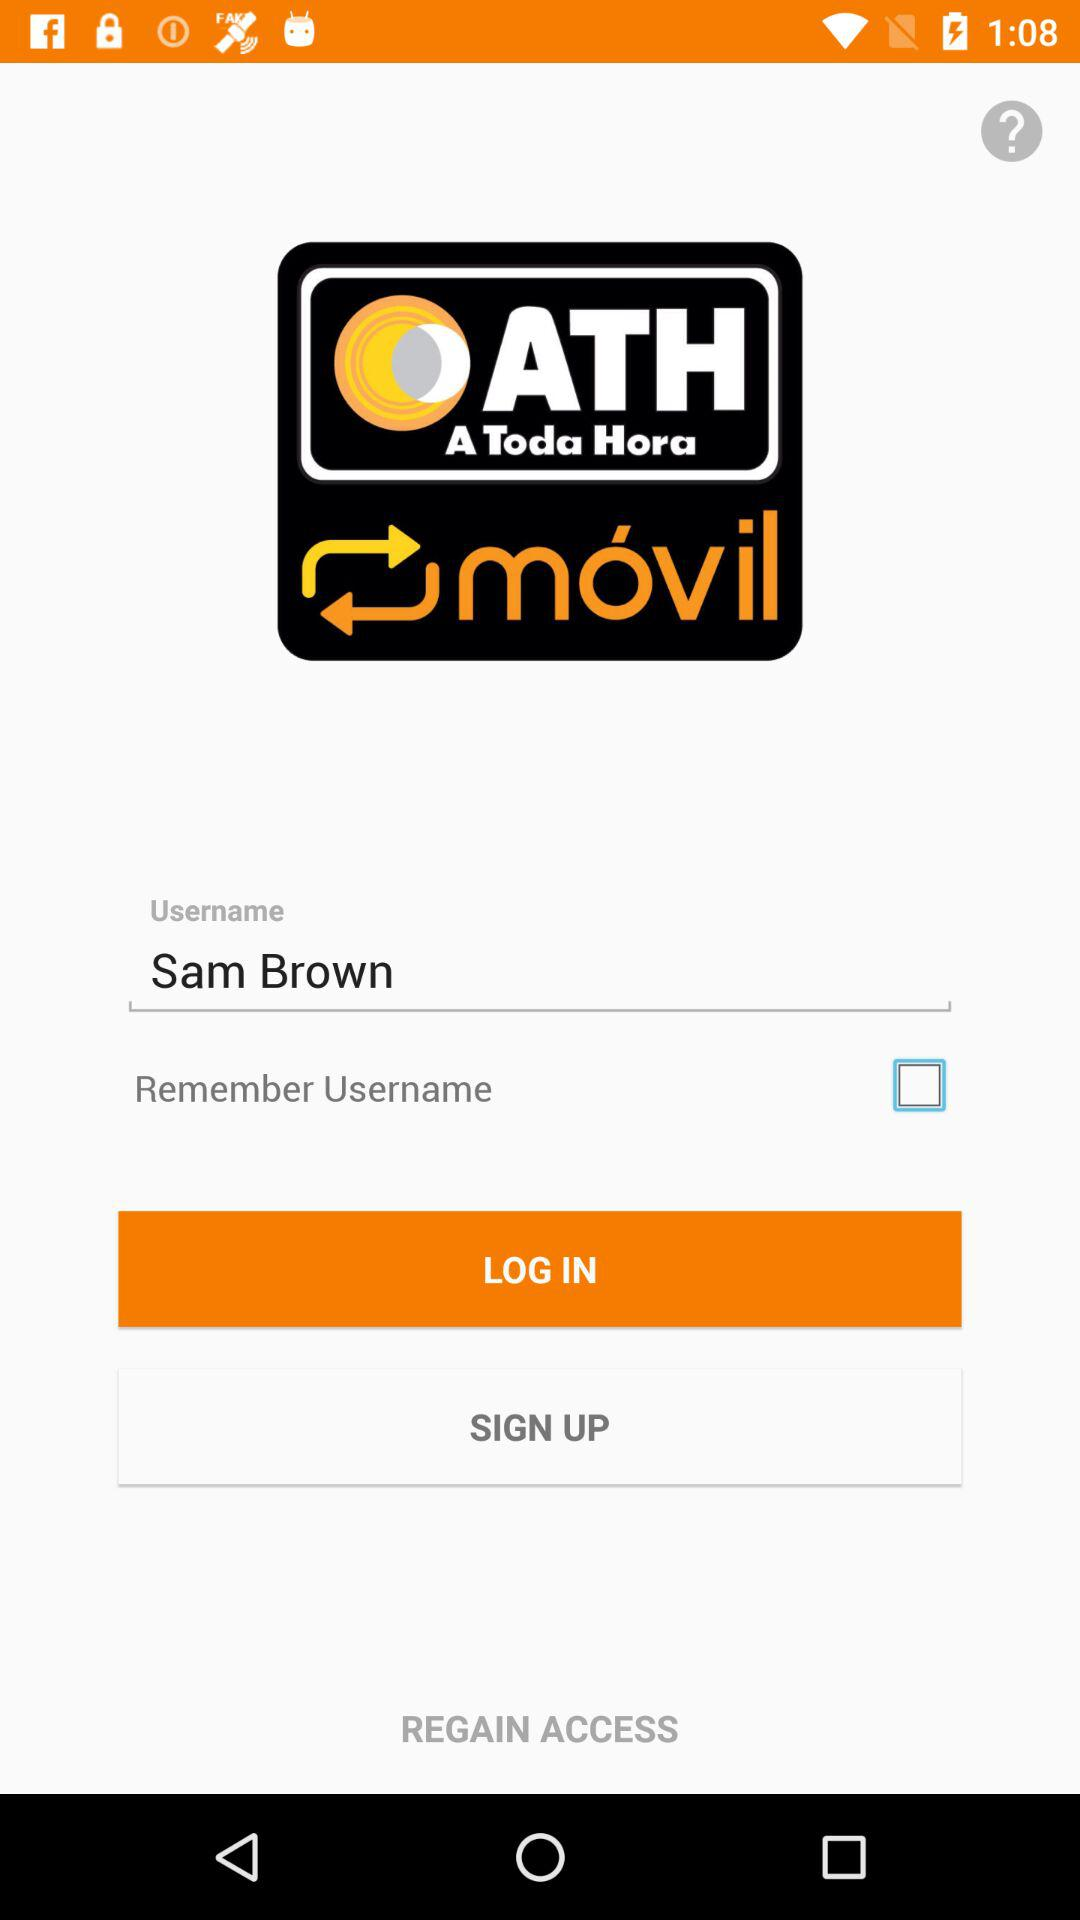What is the name of the user? The name of the user is Sam Brown. 